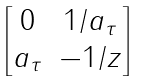<formula> <loc_0><loc_0><loc_500><loc_500>\begin{bmatrix} 0 & 1 / a _ { \tau } \\ a _ { \tau } & - 1 / z \end{bmatrix}</formula> 